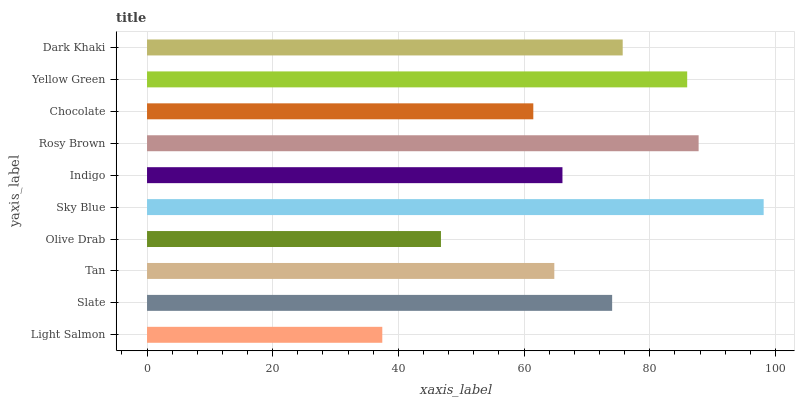Is Light Salmon the minimum?
Answer yes or no. Yes. Is Sky Blue the maximum?
Answer yes or no. Yes. Is Slate the minimum?
Answer yes or no. No. Is Slate the maximum?
Answer yes or no. No. Is Slate greater than Light Salmon?
Answer yes or no. Yes. Is Light Salmon less than Slate?
Answer yes or no. Yes. Is Light Salmon greater than Slate?
Answer yes or no. No. Is Slate less than Light Salmon?
Answer yes or no. No. Is Slate the high median?
Answer yes or no. Yes. Is Indigo the low median?
Answer yes or no. Yes. Is Chocolate the high median?
Answer yes or no. No. Is Rosy Brown the low median?
Answer yes or no. No. 